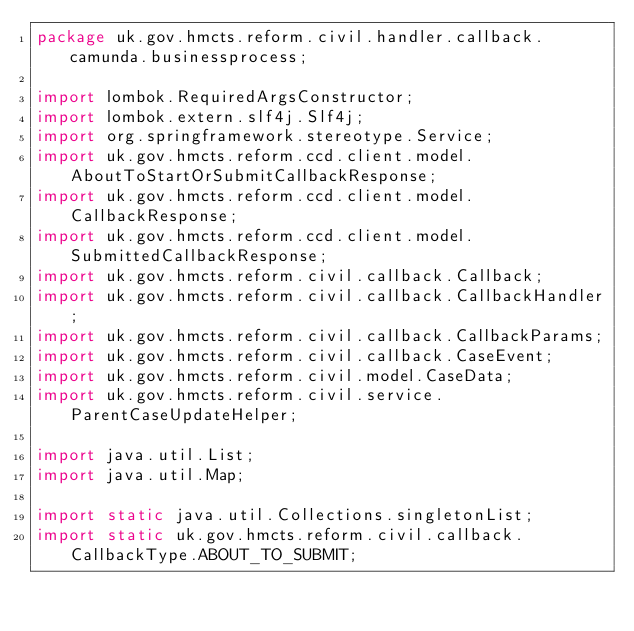Convert code to text. <code><loc_0><loc_0><loc_500><loc_500><_Java_>package uk.gov.hmcts.reform.civil.handler.callback.camunda.businessprocess;

import lombok.RequiredArgsConstructor;
import lombok.extern.slf4j.Slf4j;
import org.springframework.stereotype.Service;
import uk.gov.hmcts.reform.ccd.client.model.AboutToStartOrSubmitCallbackResponse;
import uk.gov.hmcts.reform.ccd.client.model.CallbackResponse;
import uk.gov.hmcts.reform.ccd.client.model.SubmittedCallbackResponse;
import uk.gov.hmcts.reform.civil.callback.Callback;
import uk.gov.hmcts.reform.civil.callback.CallbackHandler;
import uk.gov.hmcts.reform.civil.callback.CallbackParams;
import uk.gov.hmcts.reform.civil.callback.CaseEvent;
import uk.gov.hmcts.reform.civil.model.CaseData;
import uk.gov.hmcts.reform.civil.service.ParentCaseUpdateHelper;

import java.util.List;
import java.util.Map;

import static java.util.Collections.singletonList;
import static uk.gov.hmcts.reform.civil.callback.CallbackType.ABOUT_TO_SUBMIT;</code> 